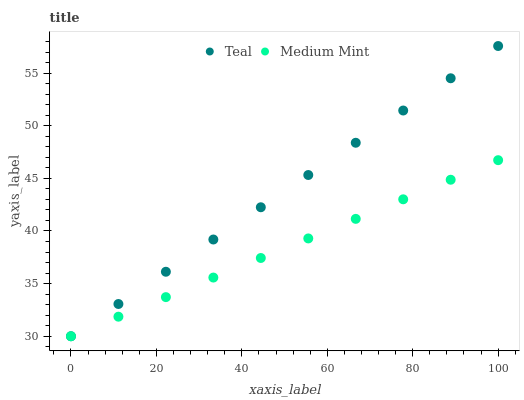Does Medium Mint have the minimum area under the curve?
Answer yes or no. Yes. Does Teal have the maximum area under the curve?
Answer yes or no. Yes. Does Teal have the minimum area under the curve?
Answer yes or no. No. Is Medium Mint the smoothest?
Answer yes or no. Yes. Is Teal the roughest?
Answer yes or no. Yes. Is Teal the smoothest?
Answer yes or no. No. Does Medium Mint have the lowest value?
Answer yes or no. Yes. Does Teal have the highest value?
Answer yes or no. Yes. Does Medium Mint intersect Teal?
Answer yes or no. Yes. Is Medium Mint less than Teal?
Answer yes or no. No. Is Medium Mint greater than Teal?
Answer yes or no. No. 